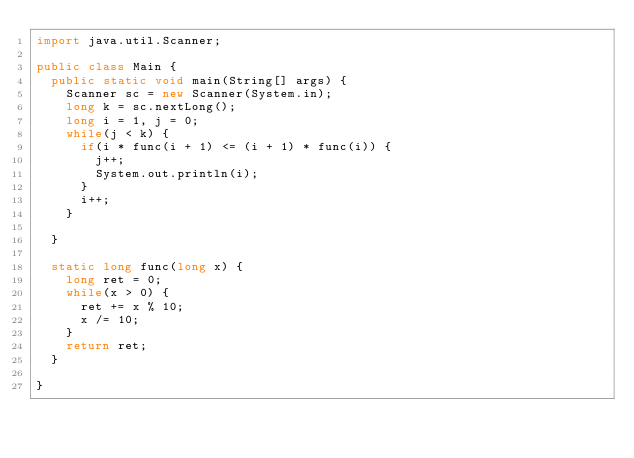Convert code to text. <code><loc_0><loc_0><loc_500><loc_500><_Java_>import java.util.Scanner;

public class Main {
	public static void main(String[] args) {
		Scanner sc = new Scanner(System.in);
		long k = sc.nextLong();
		long i = 1, j = 0;
		while(j < k) {
			if(i * func(i + 1) <= (i + 1) * func(i)) {
				j++;
				System.out.println(i);
			}
			i++;
		}

	}

	static long func(long x) {
		long ret = 0;
		while(x > 0) {
			ret += x % 10;
			x /= 10;
		}
		return ret;
	}

}
</code> 